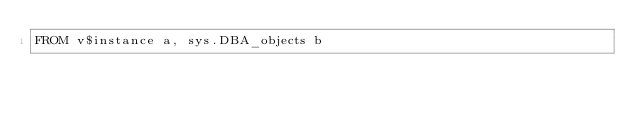Convert code to text. <code><loc_0><loc_0><loc_500><loc_500><_SQL_>FROM v$instance a, sys.DBA_objects b</code> 